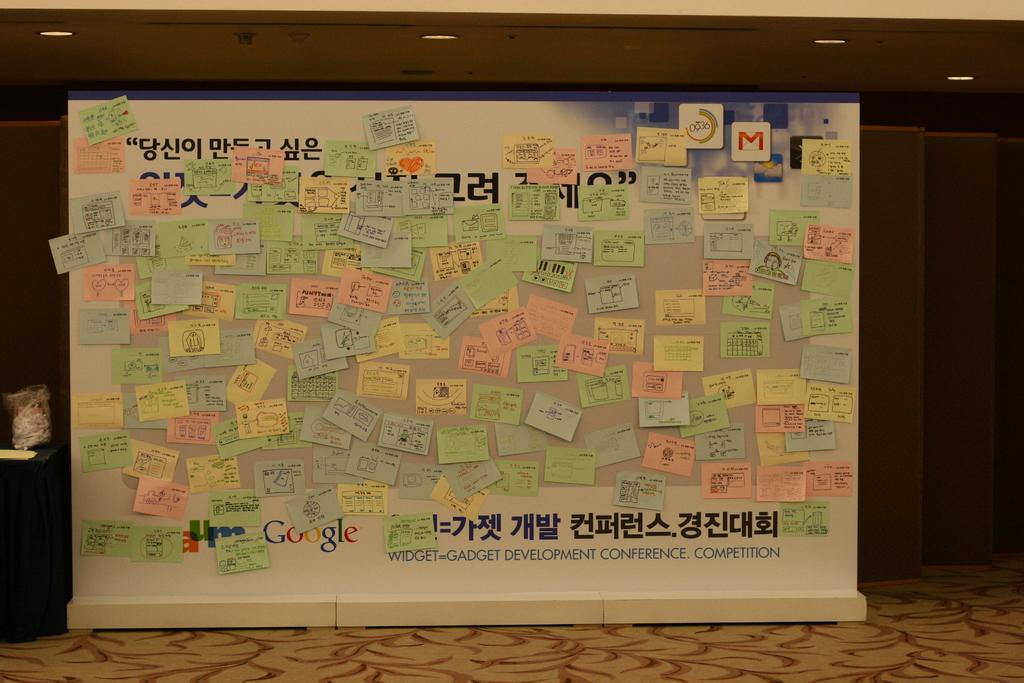Provide a one-sentence caption for the provided image. A bulletin board from a gadget development conference. 